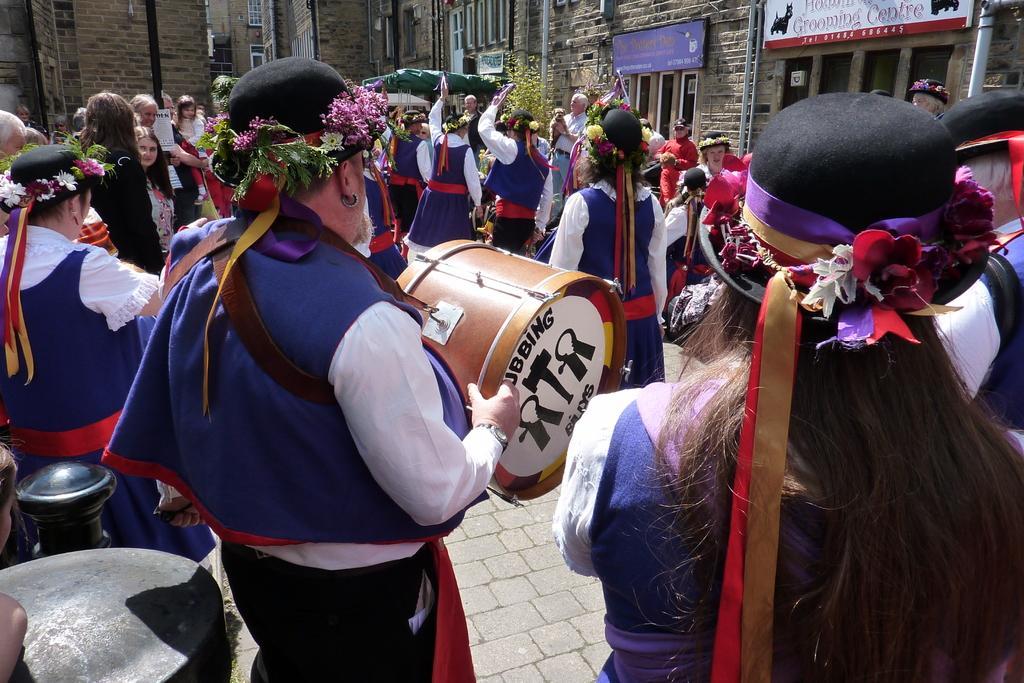Please provide a concise description of this image. In the image there are group of people who are playing their musical instruments. On left side there is a black fire extinguisher and on right side their is a building,windows,hoarding. 